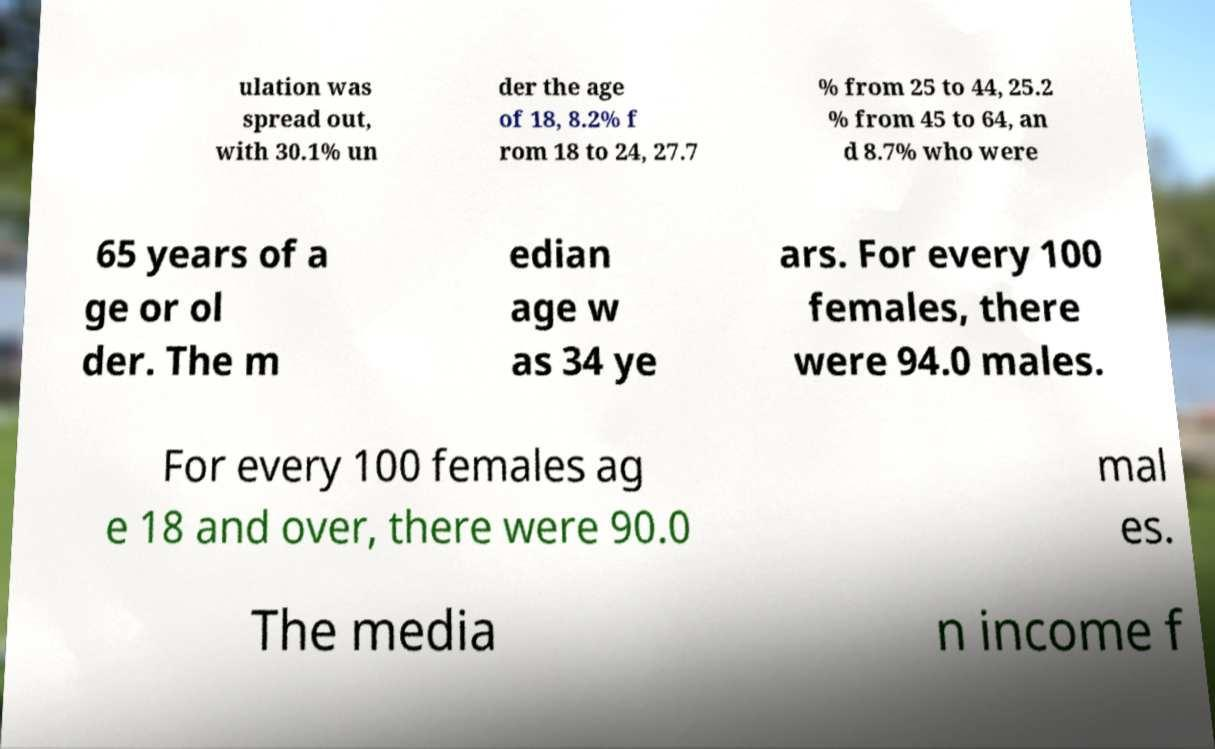Can you read and provide the text displayed in the image?This photo seems to have some interesting text. Can you extract and type it out for me? ulation was spread out, with 30.1% un der the age of 18, 8.2% f rom 18 to 24, 27.7 % from 25 to 44, 25.2 % from 45 to 64, an d 8.7% who were 65 years of a ge or ol der. The m edian age w as 34 ye ars. For every 100 females, there were 94.0 males. For every 100 females ag e 18 and over, there were 90.0 mal es. The media n income f 